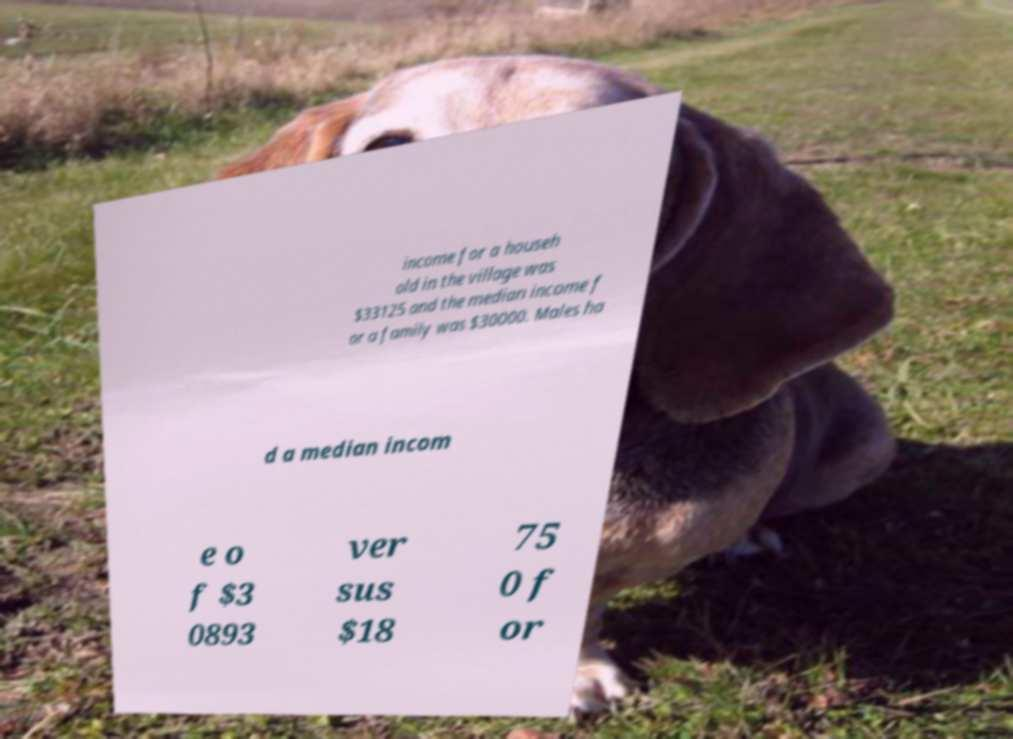Could you assist in decoding the text presented in this image and type it out clearly? income for a househ old in the village was $33125 and the median income f or a family was $30000. Males ha d a median incom e o f $3 0893 ver sus $18 75 0 f or 